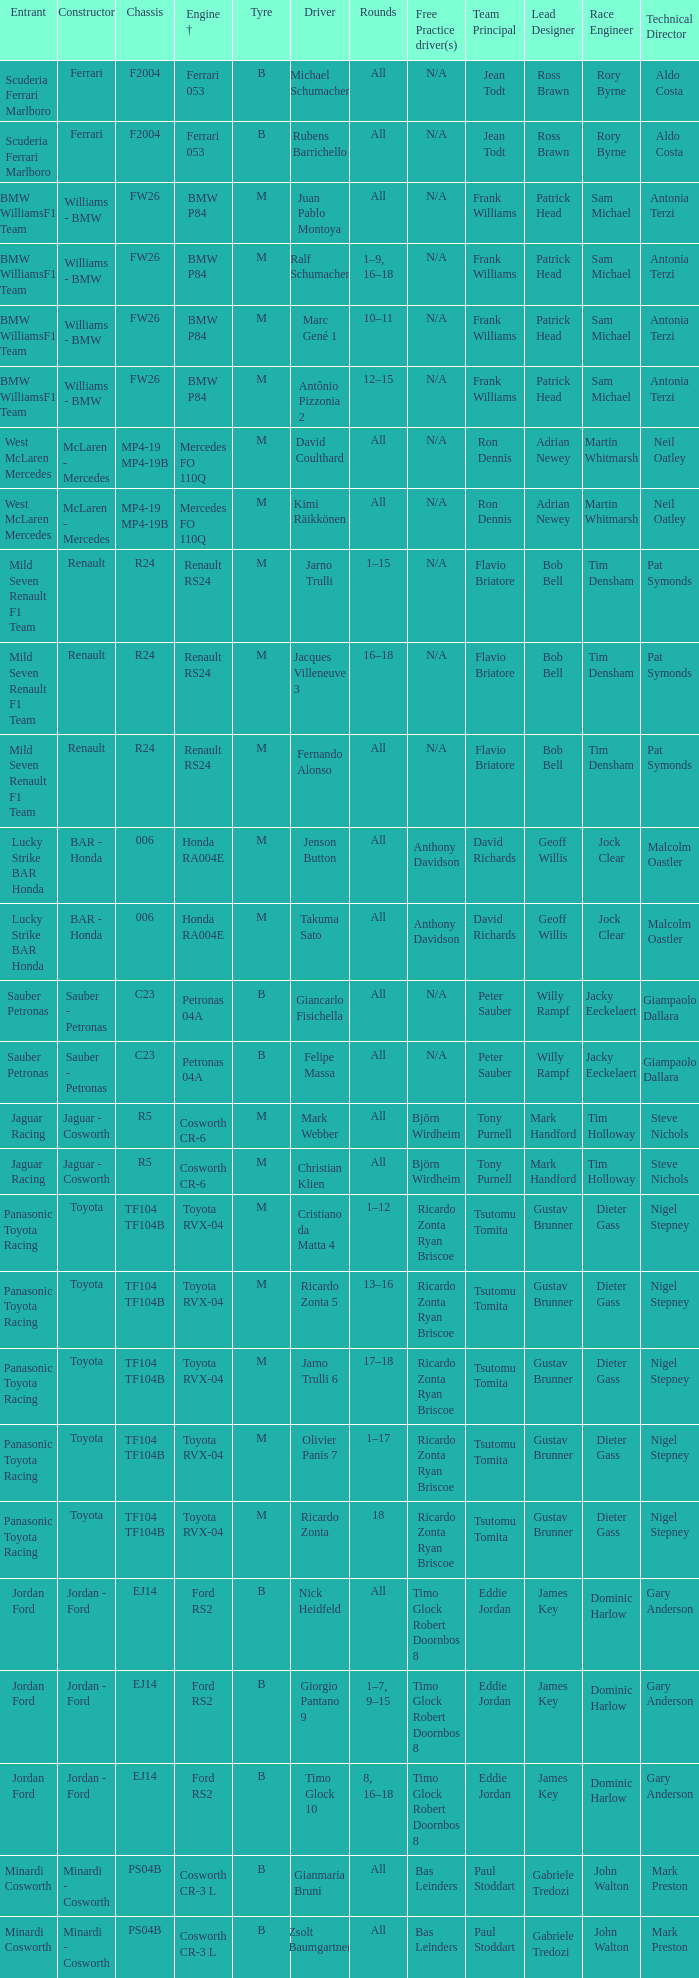What are the rounds for the B tyres and Ferrari 053 engine +? All, All. 